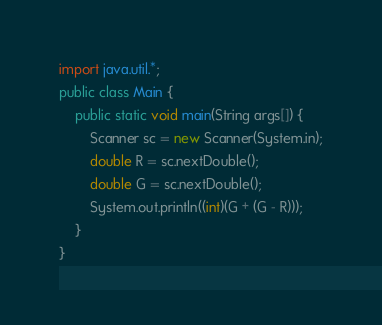Convert code to text. <code><loc_0><loc_0><loc_500><loc_500><_Java_>import java.util.*;
public class Main {
	public static void main(String args[]) {
		Scanner sc = new Scanner(System.in);
		double R = sc.nextDouble();
		double G = sc.nextDouble();
		System.out.println((int)(G + (G - R)));
	}
}
</code> 